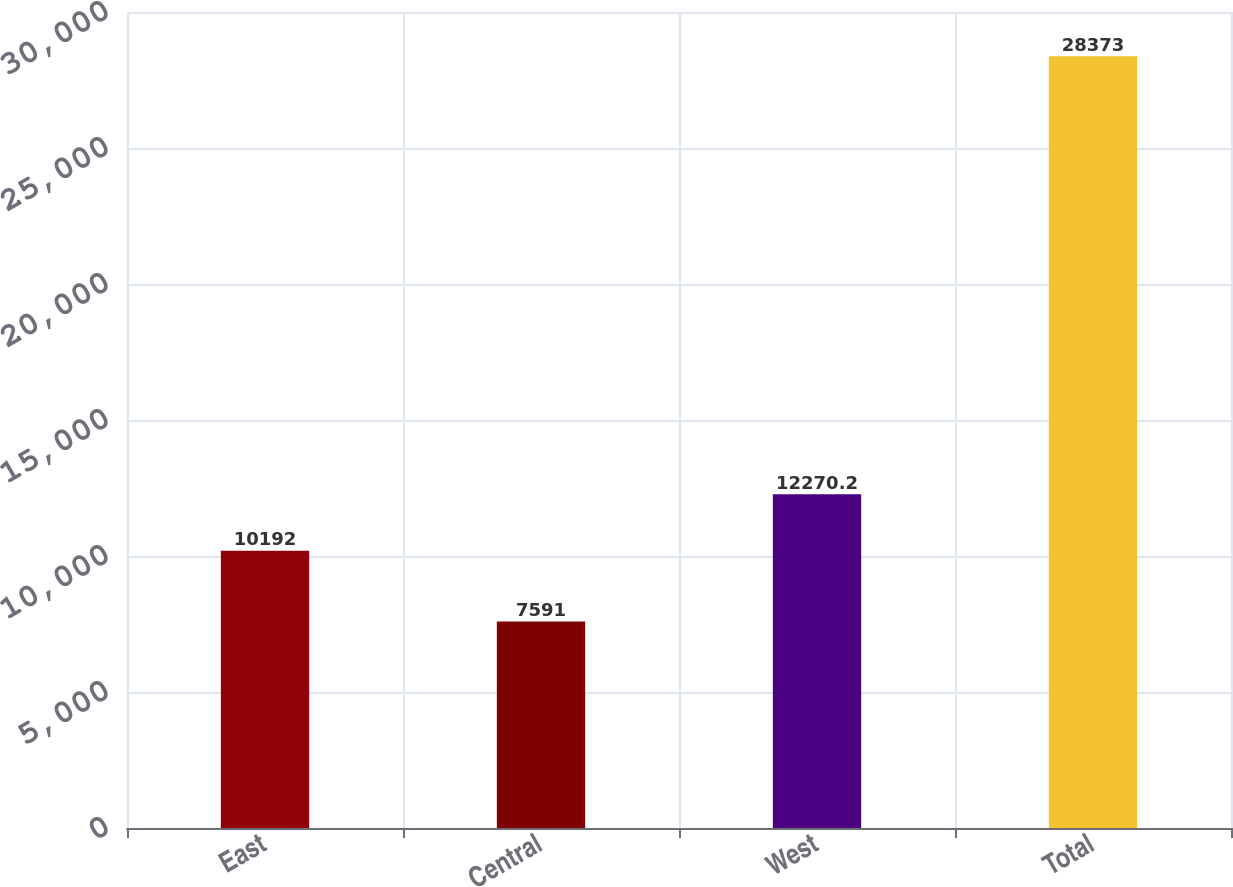Convert chart. <chart><loc_0><loc_0><loc_500><loc_500><bar_chart><fcel>East<fcel>Central<fcel>West<fcel>Total<nl><fcel>10192<fcel>7591<fcel>12270.2<fcel>28373<nl></chart> 